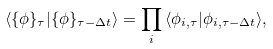Convert formula to latex. <formula><loc_0><loc_0><loc_500><loc_500>\langle \{ \phi \} _ { \tau } | \{ \phi \} _ { \tau - \Delta t } \rangle = \prod _ { i } \, \langle \phi _ { i , \tau } | \phi _ { i , \tau - \Delta t } \rangle ,</formula> 